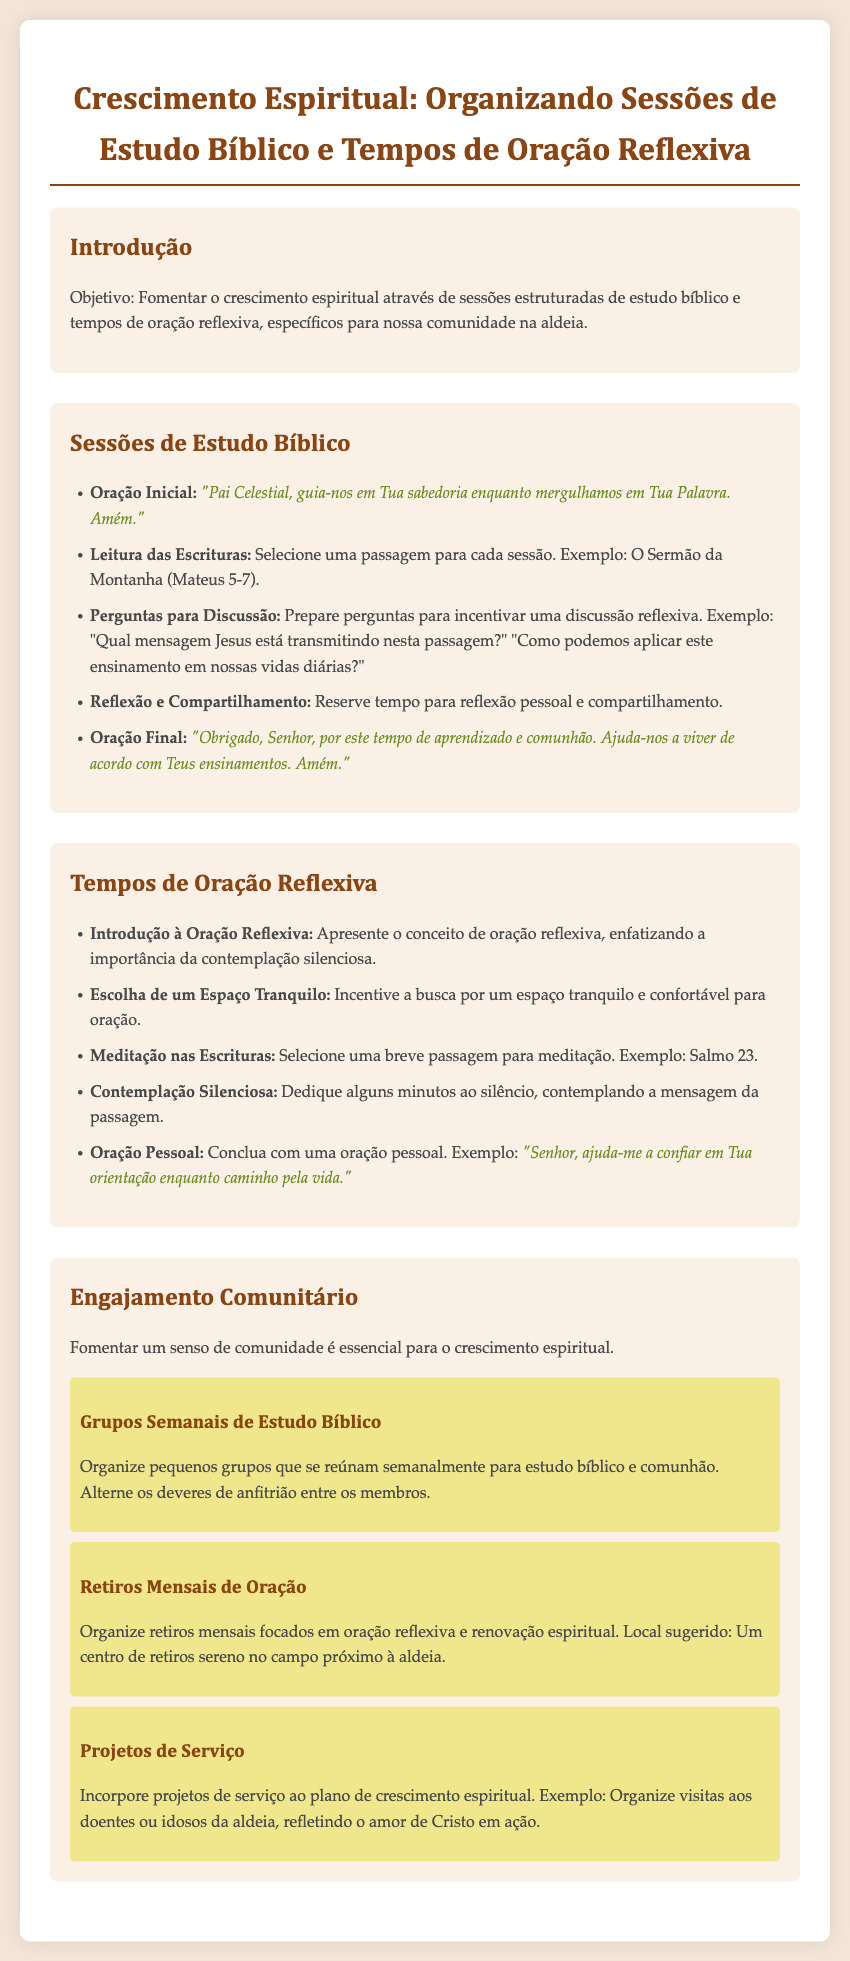Qual é o objetivo do plano de lição? O objetivo é fomentar o crescimento espiritual através de sessões estruturadas de estudo bíblico e tempos de oração reflexiva, específicos para nossa comunidade na aldeia.
Answer: Fomentar o crescimento espiritual Qual passagem é sugerida para a leitura das Escrituras? A passagem sugerida para a leitura das Escrituras como exemplo é o Sermão da Montanha, que abrange Mateus 5-7.
Answer: Mateus 5-7 Qual é a primeira oração inicial sugerida nas sessões de estudo bíblico? A oração inicial sugerida é: "Pai Celestial, guia-nos em Tua sabedoria enquanto mergulhamos em Tua Palavra. Amém."
Answer: "Pai Celestial, guia-nos em Tua sabedoria enquanto mergulhamos em Tua Palavra. Amém." Quantos grupos semanais de estudo bíblico são sugeridos no plano? O documento sugere organizar pequenos grupos, mas não menciona um número específico.
Answer: Pequenos grupos Qual é um exemplo de uma passagem para meditação nas orações reflexivas? Um exemplo de passagem para meditação é o Salmo 23.
Answer: Salmo 23 Quantas atividades de engajamento comunitário são listadas? O documento lista três atividades específicas de engajamento comunitário.
Answer: Três atividades Qual é o local sugerido para os retiros mensais de oração? O local sugerido para os retiros mensais é um centro de retiros sereno no campo próximo à aldeia.
Answer: Centro de retiros sereno no campo Qual é a atividade que envolve visitas aos doentes ou idosos da aldeia? A atividade mencionada é um projeto de serviço que incorpora visitas aos doentes ou idosos da aldeia.
Answer: Projetos de Serviço 